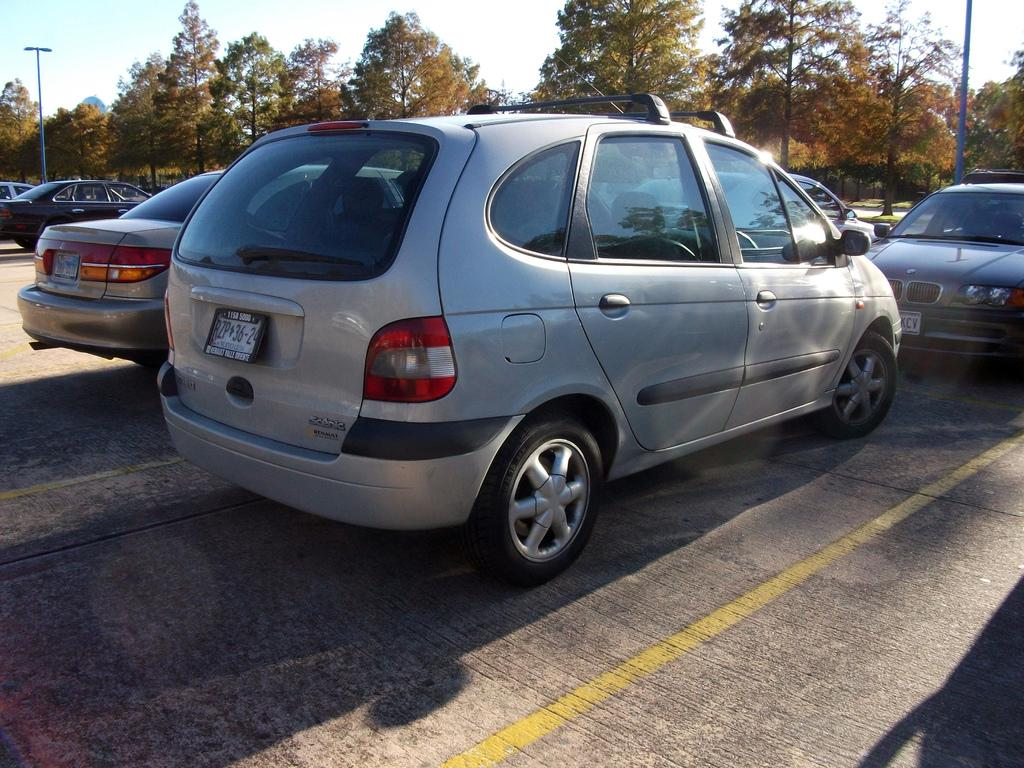What types of objects can be seen in the image? There are vehicles, poles, and trees in the image. What is visible on the ground in the image? The ground is visible in the image. What is visible in the sky in the image? The sky is visible in the image. What time of day is it in the image, based on the hour shown on the clock tower? There is no clock tower or hour mentioned in the image, so we cannot determine the time of day. How many oranges are hanging from the trees in the image? There are no oranges present in the image; it features vehicles, poles, and trees. 